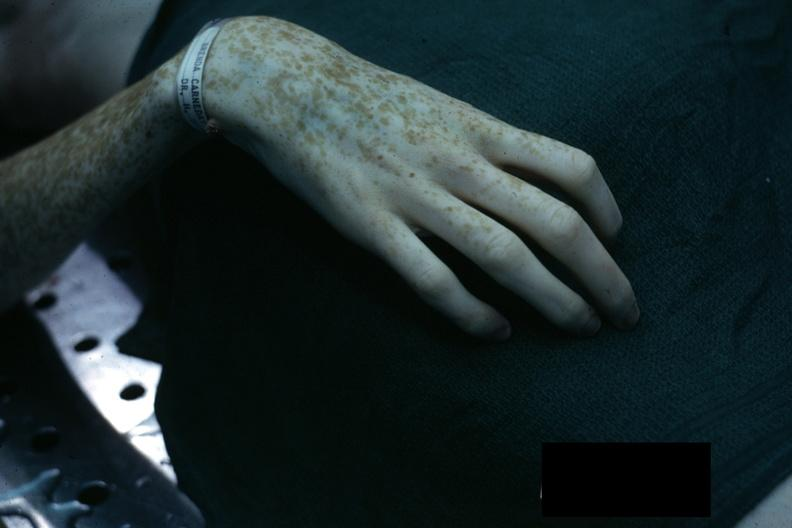does this typical lesion show excellent example of marfans syndrome?
Answer the question using a single word or phrase. No 